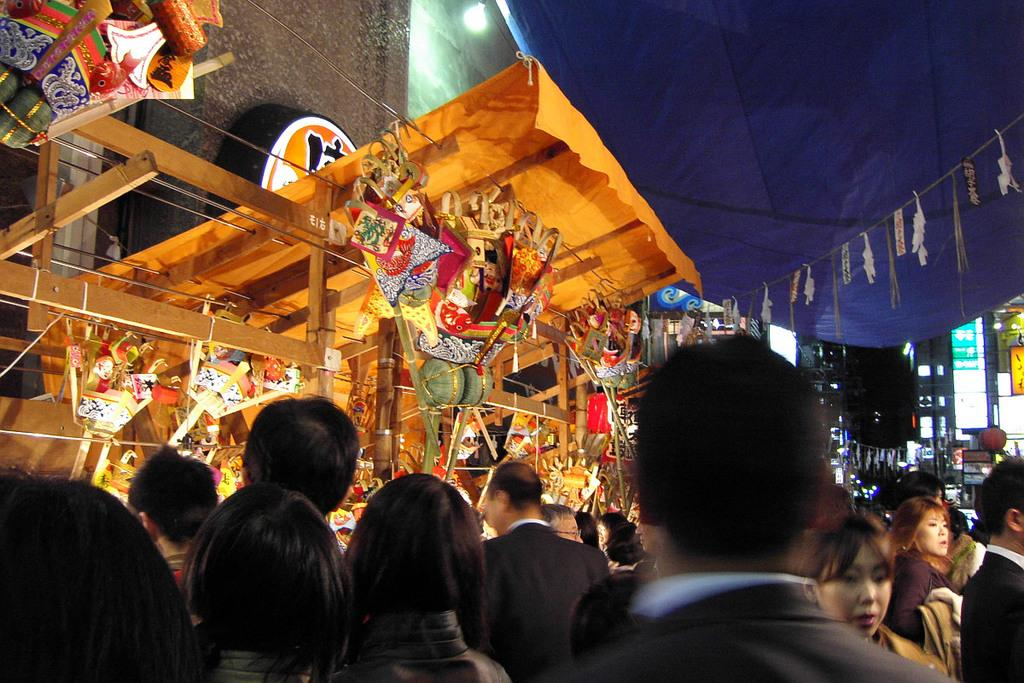What type of establishments can be seen in the image? There are stores in the image. Are there any people present in the image? Yes, there are people in the image. What can be seen illuminating the area in the image? There is a light visible in the image. What type of structures are visible in the background of the image? There are buildings in the background of the image. How would you describe the lighting conditions in the image? The background of the image appears to be a bit dark. What is the size of the fan in the image? There is no fan present in the image. 